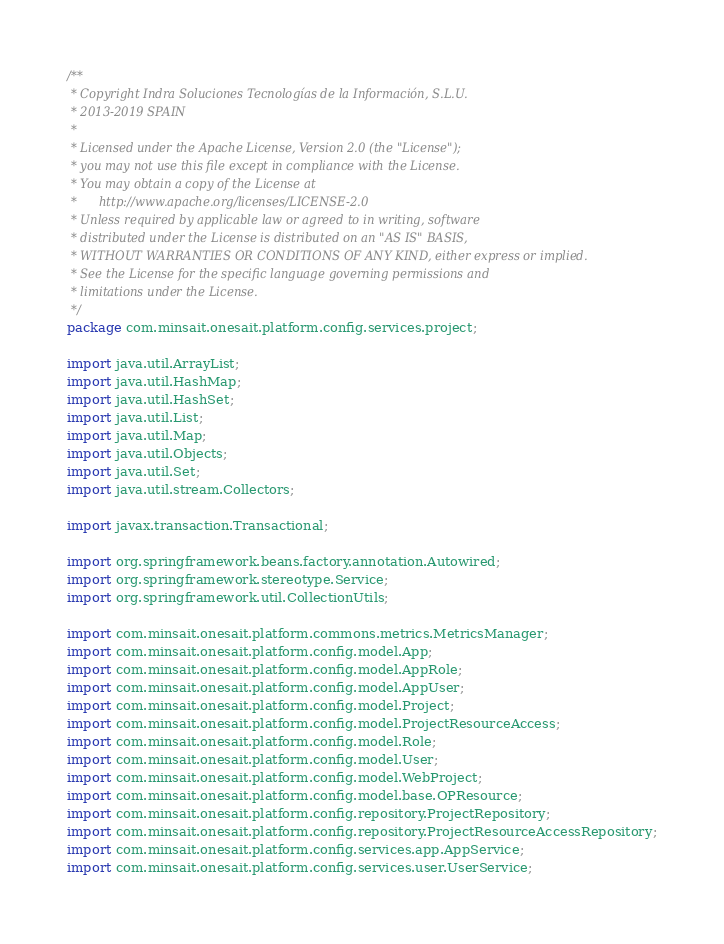Convert code to text. <code><loc_0><loc_0><loc_500><loc_500><_Java_>/**
 * Copyright Indra Soluciones Tecnologías de la Información, S.L.U.
 * 2013-2019 SPAIN
 *
 * Licensed under the Apache License, Version 2.0 (the "License");
 * you may not use this file except in compliance with the License.
 * You may obtain a copy of the License at
 *      http://www.apache.org/licenses/LICENSE-2.0
 * Unless required by applicable law or agreed to in writing, software
 * distributed under the License is distributed on an "AS IS" BASIS,
 * WITHOUT WARRANTIES OR CONDITIONS OF ANY KIND, either express or implied.
 * See the License for the specific language governing permissions and
 * limitations under the License.
 */
package com.minsait.onesait.platform.config.services.project;

import java.util.ArrayList;
import java.util.HashMap;
import java.util.HashSet;
import java.util.List;
import java.util.Map;
import java.util.Objects;
import java.util.Set;
import java.util.stream.Collectors;

import javax.transaction.Transactional;

import org.springframework.beans.factory.annotation.Autowired;
import org.springframework.stereotype.Service;
import org.springframework.util.CollectionUtils;

import com.minsait.onesait.platform.commons.metrics.MetricsManager;
import com.minsait.onesait.platform.config.model.App;
import com.minsait.onesait.platform.config.model.AppRole;
import com.minsait.onesait.platform.config.model.AppUser;
import com.minsait.onesait.platform.config.model.Project;
import com.minsait.onesait.platform.config.model.ProjectResourceAccess;
import com.minsait.onesait.platform.config.model.Role;
import com.minsait.onesait.platform.config.model.User;
import com.minsait.onesait.platform.config.model.WebProject;
import com.minsait.onesait.platform.config.model.base.OPResource;
import com.minsait.onesait.platform.config.repository.ProjectRepository;
import com.minsait.onesait.platform.config.repository.ProjectResourceAccessRepository;
import com.minsait.onesait.platform.config.services.app.AppService;
import com.minsait.onesait.platform.config.services.user.UserService;</code> 